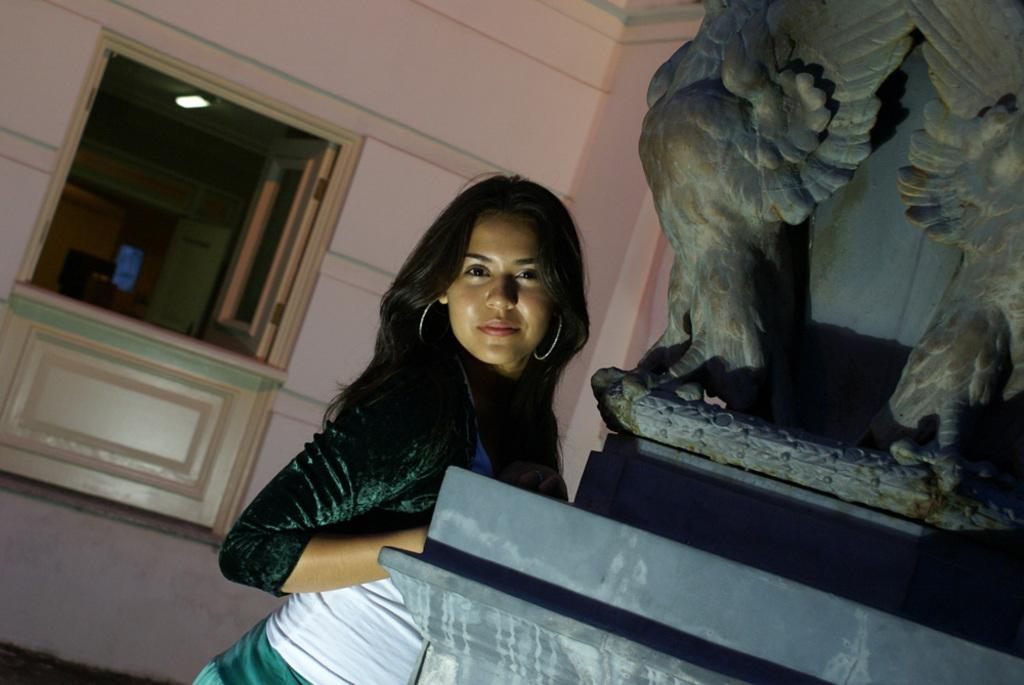What is the main subject in the image? There is a woman standing in the image. What can be seen on the stone in the image? There is a sculpture carved on a stone in the image. What is visible in the background of the image? There is a wall and a window in the background of the image. Can you tell me how many airplanes are flying in the park in the image? There are no airplanes or parks present in the image; it features a woman standing near a stone with a sculpture. Is the woman touching the sculpture in the image? The image does not provide information about whether the woman is touching the sculpture or not. 